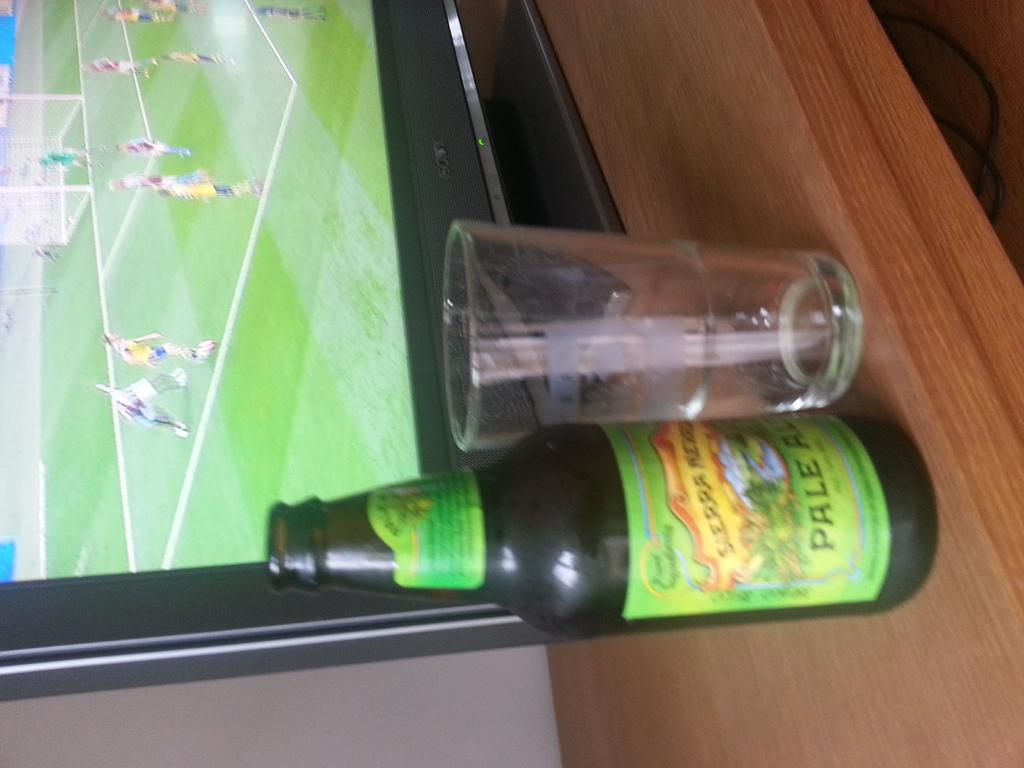<image>
Describe the image concisely. A bottle of pale ale next to a glass and a television 